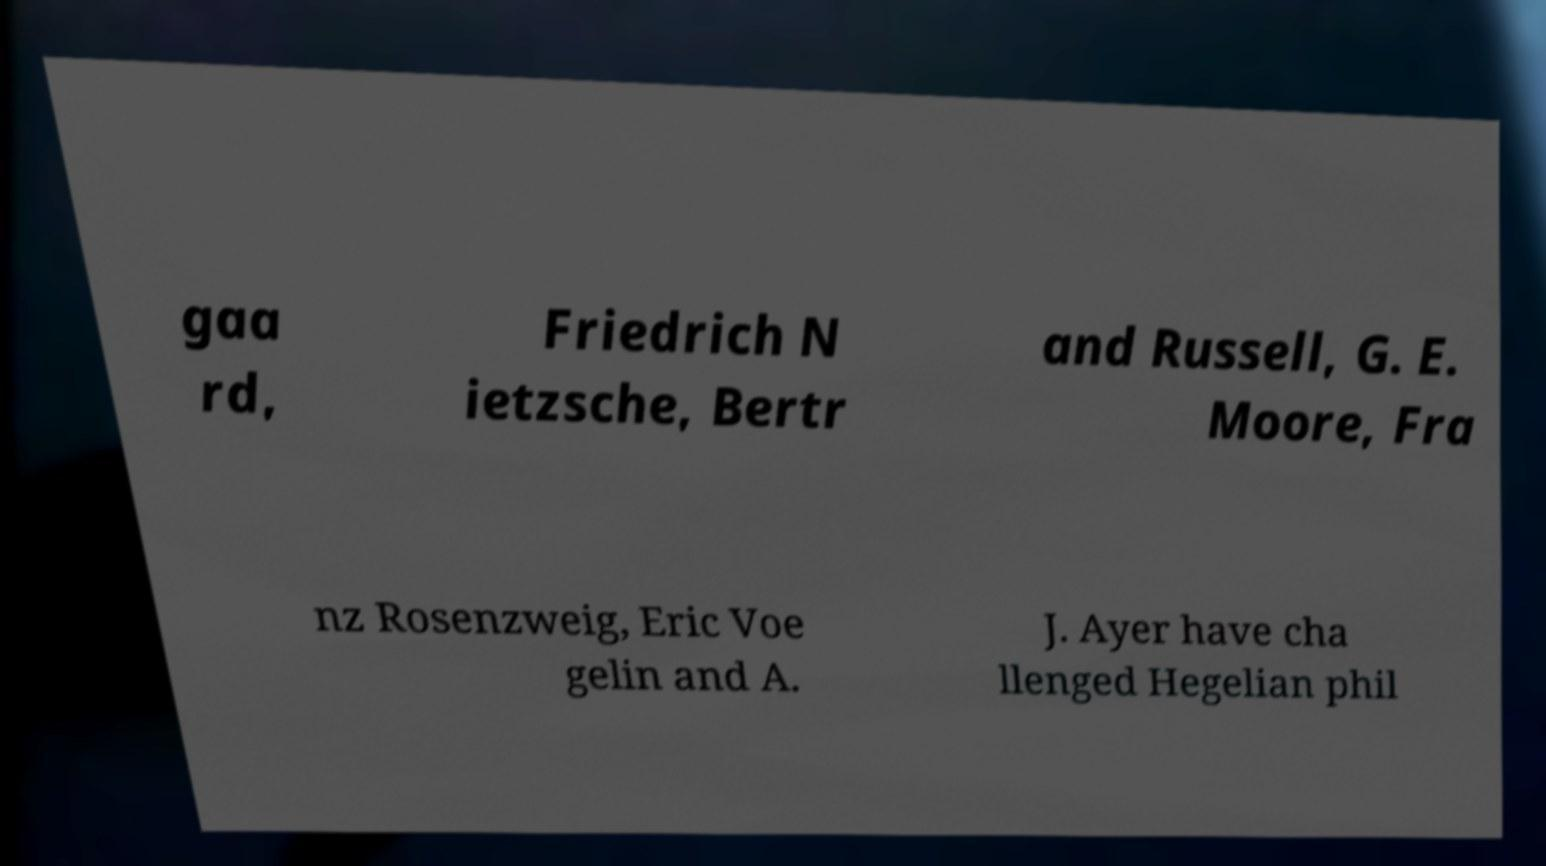Could you extract and type out the text from this image? gaa rd, Friedrich N ietzsche, Bertr and Russell, G. E. Moore, Fra nz Rosenzweig, Eric Voe gelin and A. J. Ayer have cha llenged Hegelian phil 